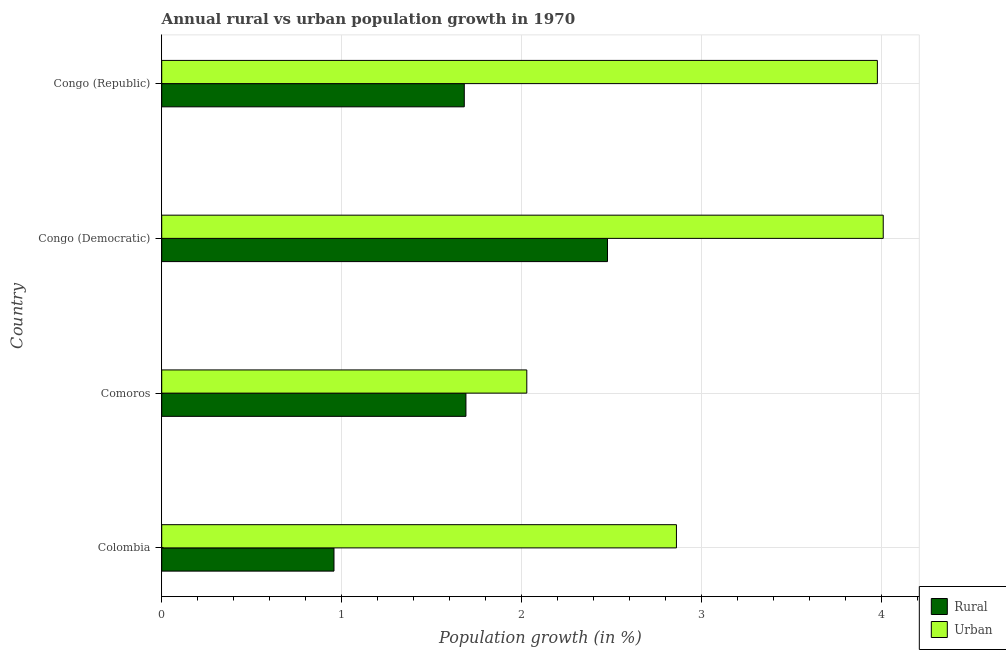How many different coloured bars are there?
Provide a succinct answer. 2. How many groups of bars are there?
Offer a terse response. 4. Are the number of bars on each tick of the Y-axis equal?
Your answer should be compact. Yes. What is the label of the 3rd group of bars from the top?
Offer a terse response. Comoros. In how many cases, is the number of bars for a given country not equal to the number of legend labels?
Keep it short and to the point. 0. What is the urban population growth in Congo (Democratic)?
Offer a very short reply. 4.01. Across all countries, what is the maximum rural population growth?
Provide a succinct answer. 2.48. Across all countries, what is the minimum urban population growth?
Your answer should be compact. 2.03. In which country was the urban population growth maximum?
Your answer should be very brief. Congo (Democratic). In which country was the urban population growth minimum?
Make the answer very short. Comoros. What is the total urban population growth in the graph?
Ensure brevity in your answer.  12.88. What is the difference between the urban population growth in Congo (Democratic) and that in Congo (Republic)?
Give a very brief answer. 0.03. What is the difference between the urban population growth in Colombia and the rural population growth in Comoros?
Provide a succinct answer. 1.17. What is the average urban population growth per country?
Provide a short and direct response. 3.22. What is the difference between the rural population growth and urban population growth in Comoros?
Your response must be concise. -0.34. What is the ratio of the rural population growth in Colombia to that in Comoros?
Provide a short and direct response. 0.57. Is the rural population growth in Comoros less than that in Congo (Republic)?
Keep it short and to the point. No. What is the difference between the highest and the second highest rural population growth?
Your response must be concise. 0.79. What is the difference between the highest and the lowest urban population growth?
Provide a short and direct response. 1.98. In how many countries, is the rural population growth greater than the average rural population growth taken over all countries?
Ensure brevity in your answer.  1. Is the sum of the urban population growth in Comoros and Congo (Republic) greater than the maximum rural population growth across all countries?
Provide a succinct answer. Yes. What does the 1st bar from the top in Congo (Democratic) represents?
Provide a short and direct response. Urban . What does the 1st bar from the bottom in Colombia represents?
Keep it short and to the point. Rural. How many bars are there?
Offer a terse response. 8. How many countries are there in the graph?
Give a very brief answer. 4. Are the values on the major ticks of X-axis written in scientific E-notation?
Keep it short and to the point. No. Does the graph contain any zero values?
Your answer should be compact. No. How are the legend labels stacked?
Ensure brevity in your answer.  Vertical. What is the title of the graph?
Provide a succinct answer. Annual rural vs urban population growth in 1970. What is the label or title of the X-axis?
Your response must be concise. Population growth (in %). What is the Population growth (in %) in Rural in Colombia?
Make the answer very short. 0.96. What is the Population growth (in %) of Urban  in Colombia?
Your answer should be very brief. 2.86. What is the Population growth (in %) in Rural in Comoros?
Keep it short and to the point. 1.69. What is the Population growth (in %) in Urban  in Comoros?
Give a very brief answer. 2.03. What is the Population growth (in %) of Rural in Congo (Democratic)?
Your answer should be compact. 2.48. What is the Population growth (in %) in Urban  in Congo (Democratic)?
Your answer should be compact. 4.01. What is the Population growth (in %) in Rural in Congo (Republic)?
Provide a succinct answer. 1.68. What is the Population growth (in %) in Urban  in Congo (Republic)?
Make the answer very short. 3.98. Across all countries, what is the maximum Population growth (in %) of Rural?
Keep it short and to the point. 2.48. Across all countries, what is the maximum Population growth (in %) of Urban ?
Your answer should be compact. 4.01. Across all countries, what is the minimum Population growth (in %) in Rural?
Offer a terse response. 0.96. Across all countries, what is the minimum Population growth (in %) in Urban ?
Provide a short and direct response. 2.03. What is the total Population growth (in %) of Rural in the graph?
Your answer should be compact. 6.81. What is the total Population growth (in %) in Urban  in the graph?
Offer a terse response. 12.88. What is the difference between the Population growth (in %) of Rural in Colombia and that in Comoros?
Provide a short and direct response. -0.73. What is the difference between the Population growth (in %) of Urban  in Colombia and that in Comoros?
Give a very brief answer. 0.83. What is the difference between the Population growth (in %) in Rural in Colombia and that in Congo (Democratic)?
Offer a very short reply. -1.52. What is the difference between the Population growth (in %) in Urban  in Colombia and that in Congo (Democratic)?
Provide a succinct answer. -1.15. What is the difference between the Population growth (in %) of Rural in Colombia and that in Congo (Republic)?
Provide a succinct answer. -0.72. What is the difference between the Population growth (in %) of Urban  in Colombia and that in Congo (Republic)?
Your answer should be compact. -1.12. What is the difference between the Population growth (in %) of Rural in Comoros and that in Congo (Democratic)?
Your response must be concise. -0.79. What is the difference between the Population growth (in %) in Urban  in Comoros and that in Congo (Democratic)?
Your response must be concise. -1.98. What is the difference between the Population growth (in %) in Rural in Comoros and that in Congo (Republic)?
Offer a very short reply. 0.01. What is the difference between the Population growth (in %) in Urban  in Comoros and that in Congo (Republic)?
Keep it short and to the point. -1.95. What is the difference between the Population growth (in %) of Rural in Congo (Democratic) and that in Congo (Republic)?
Your response must be concise. 0.8. What is the difference between the Population growth (in %) in Urban  in Congo (Democratic) and that in Congo (Republic)?
Your answer should be very brief. 0.03. What is the difference between the Population growth (in %) of Rural in Colombia and the Population growth (in %) of Urban  in Comoros?
Offer a terse response. -1.07. What is the difference between the Population growth (in %) in Rural in Colombia and the Population growth (in %) in Urban  in Congo (Democratic)?
Provide a short and direct response. -3.05. What is the difference between the Population growth (in %) of Rural in Colombia and the Population growth (in %) of Urban  in Congo (Republic)?
Provide a short and direct response. -3.02. What is the difference between the Population growth (in %) of Rural in Comoros and the Population growth (in %) of Urban  in Congo (Democratic)?
Give a very brief answer. -2.32. What is the difference between the Population growth (in %) of Rural in Comoros and the Population growth (in %) of Urban  in Congo (Republic)?
Make the answer very short. -2.29. What is the difference between the Population growth (in %) of Rural in Congo (Democratic) and the Population growth (in %) of Urban  in Congo (Republic)?
Keep it short and to the point. -1.5. What is the average Population growth (in %) in Rural per country?
Give a very brief answer. 1.7. What is the average Population growth (in %) of Urban  per country?
Offer a very short reply. 3.22. What is the difference between the Population growth (in %) of Rural and Population growth (in %) of Urban  in Colombia?
Offer a very short reply. -1.9. What is the difference between the Population growth (in %) in Rural and Population growth (in %) in Urban  in Comoros?
Give a very brief answer. -0.34. What is the difference between the Population growth (in %) in Rural and Population growth (in %) in Urban  in Congo (Democratic)?
Give a very brief answer. -1.53. What is the difference between the Population growth (in %) in Rural and Population growth (in %) in Urban  in Congo (Republic)?
Ensure brevity in your answer.  -2.3. What is the ratio of the Population growth (in %) of Rural in Colombia to that in Comoros?
Your answer should be very brief. 0.57. What is the ratio of the Population growth (in %) in Urban  in Colombia to that in Comoros?
Offer a terse response. 1.41. What is the ratio of the Population growth (in %) in Rural in Colombia to that in Congo (Democratic)?
Your answer should be very brief. 0.39. What is the ratio of the Population growth (in %) of Urban  in Colombia to that in Congo (Democratic)?
Provide a succinct answer. 0.71. What is the ratio of the Population growth (in %) in Rural in Colombia to that in Congo (Republic)?
Your answer should be very brief. 0.57. What is the ratio of the Population growth (in %) of Urban  in Colombia to that in Congo (Republic)?
Keep it short and to the point. 0.72. What is the ratio of the Population growth (in %) of Rural in Comoros to that in Congo (Democratic)?
Provide a short and direct response. 0.68. What is the ratio of the Population growth (in %) of Urban  in Comoros to that in Congo (Democratic)?
Ensure brevity in your answer.  0.51. What is the ratio of the Population growth (in %) of Urban  in Comoros to that in Congo (Republic)?
Provide a succinct answer. 0.51. What is the ratio of the Population growth (in %) in Rural in Congo (Democratic) to that in Congo (Republic)?
Your response must be concise. 1.47. What is the ratio of the Population growth (in %) of Urban  in Congo (Democratic) to that in Congo (Republic)?
Provide a short and direct response. 1.01. What is the difference between the highest and the second highest Population growth (in %) of Rural?
Offer a terse response. 0.79. What is the difference between the highest and the second highest Population growth (in %) in Urban ?
Provide a succinct answer. 0.03. What is the difference between the highest and the lowest Population growth (in %) of Rural?
Offer a very short reply. 1.52. What is the difference between the highest and the lowest Population growth (in %) of Urban ?
Make the answer very short. 1.98. 